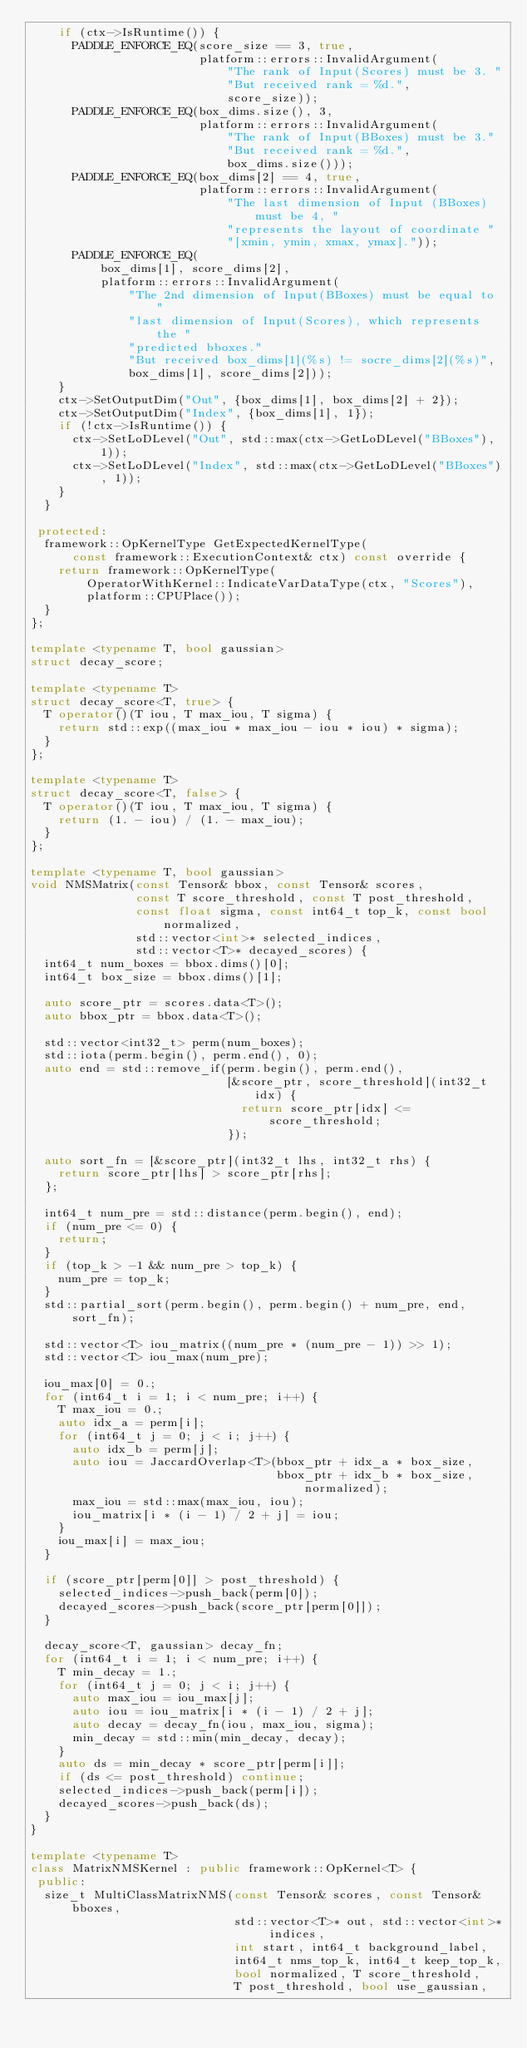<code> <loc_0><loc_0><loc_500><loc_500><_C++_>    if (ctx->IsRuntime()) {
      PADDLE_ENFORCE_EQ(score_size == 3, true,
                        platform::errors::InvalidArgument(
                            "The rank of Input(Scores) must be 3. "
                            "But received rank = %d.",
                            score_size));
      PADDLE_ENFORCE_EQ(box_dims.size(), 3,
                        platform::errors::InvalidArgument(
                            "The rank of Input(BBoxes) must be 3."
                            "But received rank = %d.",
                            box_dims.size()));
      PADDLE_ENFORCE_EQ(box_dims[2] == 4, true,
                        platform::errors::InvalidArgument(
                            "The last dimension of Input (BBoxes) must be 4, "
                            "represents the layout of coordinate "
                            "[xmin, ymin, xmax, ymax]."));
      PADDLE_ENFORCE_EQ(
          box_dims[1], score_dims[2],
          platform::errors::InvalidArgument(
              "The 2nd dimension of Input(BBoxes) must be equal to "
              "last dimension of Input(Scores), which represents the "
              "predicted bboxes."
              "But received box_dims[1](%s) != socre_dims[2](%s)",
              box_dims[1], score_dims[2]));
    }
    ctx->SetOutputDim("Out", {box_dims[1], box_dims[2] + 2});
    ctx->SetOutputDim("Index", {box_dims[1], 1});
    if (!ctx->IsRuntime()) {
      ctx->SetLoDLevel("Out", std::max(ctx->GetLoDLevel("BBoxes"), 1));
      ctx->SetLoDLevel("Index", std::max(ctx->GetLoDLevel("BBoxes"), 1));
    }
  }

 protected:
  framework::OpKernelType GetExpectedKernelType(
      const framework::ExecutionContext& ctx) const override {
    return framework::OpKernelType(
        OperatorWithKernel::IndicateVarDataType(ctx, "Scores"),
        platform::CPUPlace());
  }
};

template <typename T, bool gaussian>
struct decay_score;

template <typename T>
struct decay_score<T, true> {
  T operator()(T iou, T max_iou, T sigma) {
    return std::exp((max_iou * max_iou - iou * iou) * sigma);
  }
};

template <typename T>
struct decay_score<T, false> {
  T operator()(T iou, T max_iou, T sigma) {
    return (1. - iou) / (1. - max_iou);
  }
};

template <typename T, bool gaussian>
void NMSMatrix(const Tensor& bbox, const Tensor& scores,
               const T score_threshold, const T post_threshold,
               const float sigma, const int64_t top_k, const bool normalized,
               std::vector<int>* selected_indices,
               std::vector<T>* decayed_scores) {
  int64_t num_boxes = bbox.dims()[0];
  int64_t box_size = bbox.dims()[1];

  auto score_ptr = scores.data<T>();
  auto bbox_ptr = bbox.data<T>();

  std::vector<int32_t> perm(num_boxes);
  std::iota(perm.begin(), perm.end(), 0);
  auto end = std::remove_if(perm.begin(), perm.end(),
                            [&score_ptr, score_threshold](int32_t idx) {
                              return score_ptr[idx] <= score_threshold;
                            });

  auto sort_fn = [&score_ptr](int32_t lhs, int32_t rhs) {
    return score_ptr[lhs] > score_ptr[rhs];
  };

  int64_t num_pre = std::distance(perm.begin(), end);
  if (num_pre <= 0) {
    return;
  }
  if (top_k > -1 && num_pre > top_k) {
    num_pre = top_k;
  }
  std::partial_sort(perm.begin(), perm.begin() + num_pre, end, sort_fn);

  std::vector<T> iou_matrix((num_pre * (num_pre - 1)) >> 1);
  std::vector<T> iou_max(num_pre);

  iou_max[0] = 0.;
  for (int64_t i = 1; i < num_pre; i++) {
    T max_iou = 0.;
    auto idx_a = perm[i];
    for (int64_t j = 0; j < i; j++) {
      auto idx_b = perm[j];
      auto iou = JaccardOverlap<T>(bbox_ptr + idx_a * box_size,
                                   bbox_ptr + idx_b * box_size, normalized);
      max_iou = std::max(max_iou, iou);
      iou_matrix[i * (i - 1) / 2 + j] = iou;
    }
    iou_max[i] = max_iou;
  }

  if (score_ptr[perm[0]] > post_threshold) {
    selected_indices->push_back(perm[0]);
    decayed_scores->push_back(score_ptr[perm[0]]);
  }

  decay_score<T, gaussian> decay_fn;
  for (int64_t i = 1; i < num_pre; i++) {
    T min_decay = 1.;
    for (int64_t j = 0; j < i; j++) {
      auto max_iou = iou_max[j];
      auto iou = iou_matrix[i * (i - 1) / 2 + j];
      auto decay = decay_fn(iou, max_iou, sigma);
      min_decay = std::min(min_decay, decay);
    }
    auto ds = min_decay * score_ptr[perm[i]];
    if (ds <= post_threshold) continue;
    selected_indices->push_back(perm[i]);
    decayed_scores->push_back(ds);
  }
}

template <typename T>
class MatrixNMSKernel : public framework::OpKernel<T> {
 public:
  size_t MultiClassMatrixNMS(const Tensor& scores, const Tensor& bboxes,
                             std::vector<T>* out, std::vector<int>* indices,
                             int start, int64_t background_label,
                             int64_t nms_top_k, int64_t keep_top_k,
                             bool normalized, T score_threshold,
                             T post_threshold, bool use_gaussian,</code> 